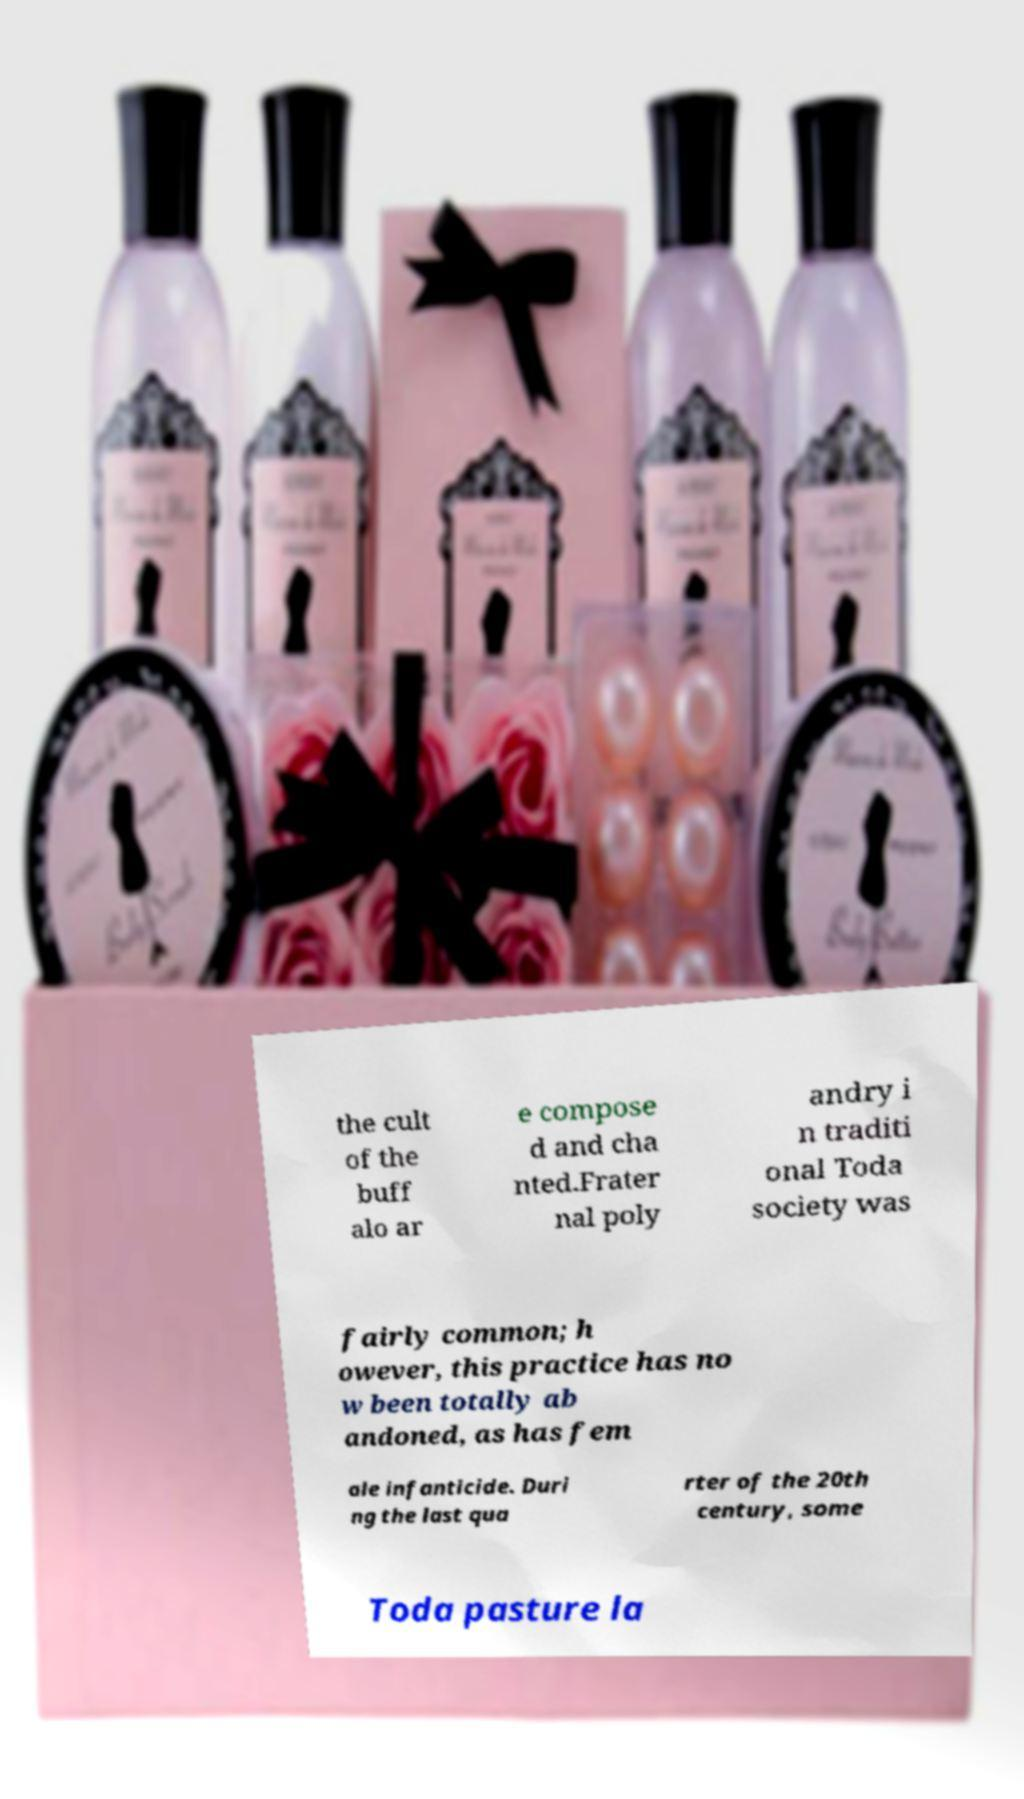I need the written content from this picture converted into text. Can you do that? the cult of the buff alo ar e compose d and cha nted.Frater nal poly andry i n traditi onal Toda society was fairly common; h owever, this practice has no w been totally ab andoned, as has fem ale infanticide. Duri ng the last qua rter of the 20th century, some Toda pasture la 